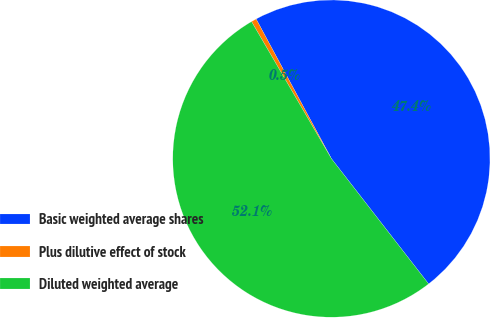<chart> <loc_0><loc_0><loc_500><loc_500><pie_chart><fcel>Basic weighted average shares<fcel>Plus dilutive effect of stock<fcel>Diluted weighted average<nl><fcel>47.37%<fcel>0.53%<fcel>52.11%<nl></chart> 